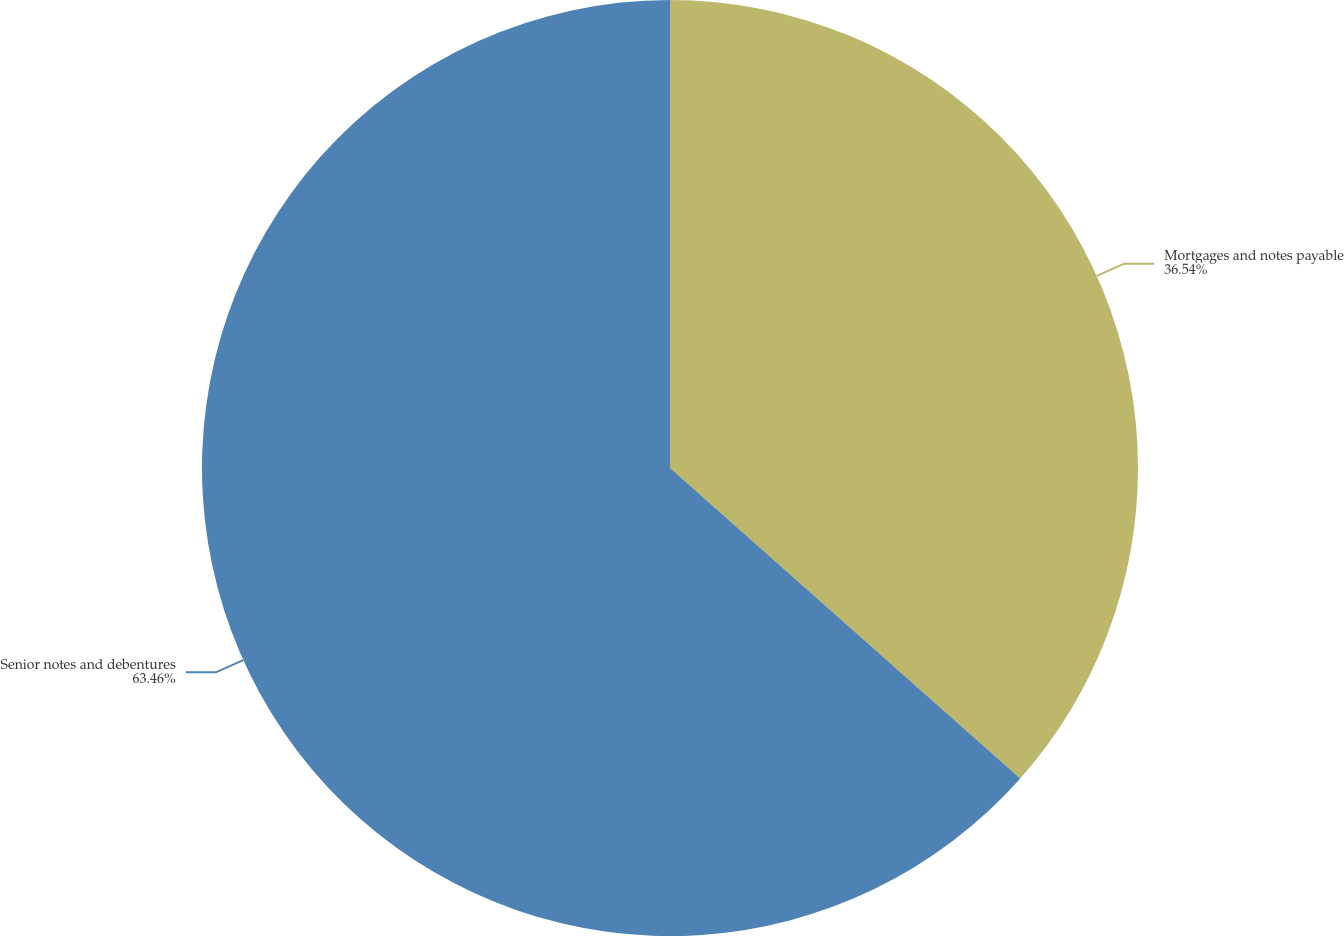<chart> <loc_0><loc_0><loc_500><loc_500><pie_chart><fcel>Mortgages and notes payable<fcel>Senior notes and debentures<nl><fcel>36.54%<fcel>63.46%<nl></chart> 